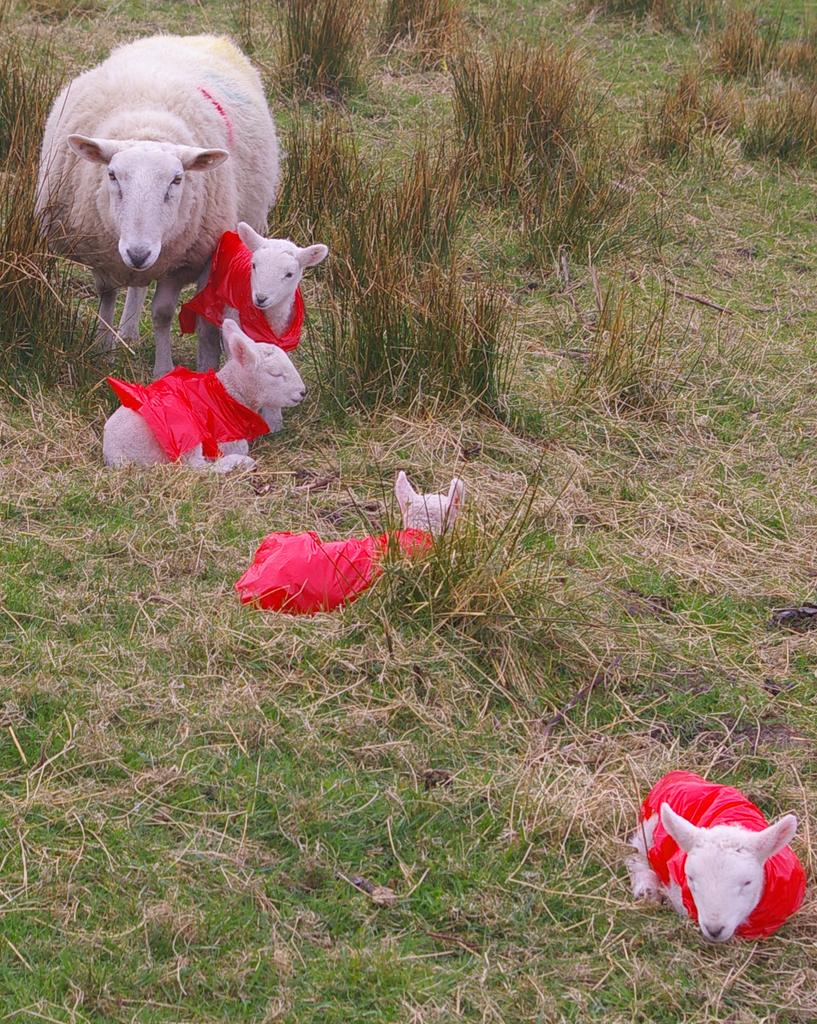What is the main subject in the center of the image? There is a sheep in the center of the image. Are there any other sheep in the image? Yes, there are small sheep in the image. What type of vegetation is present at the bottom of the image? There is grass at the bottom of the image. What type of bean is growing on the hill in the image? There is no hill or bean present in the image; it features a sheep and grass. 